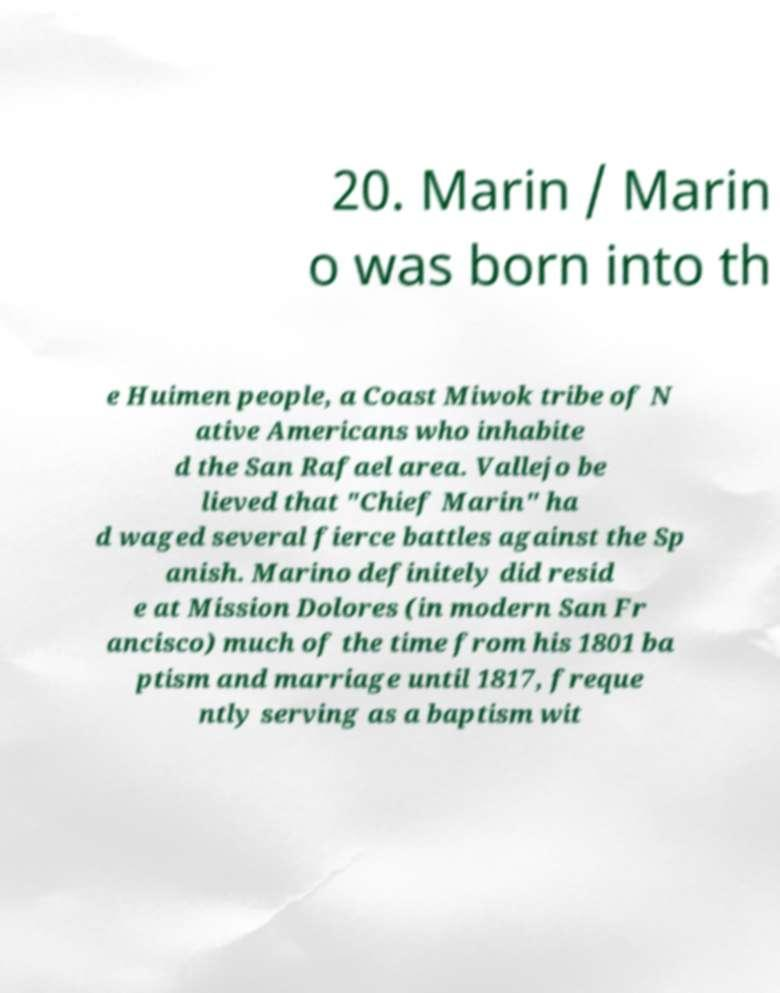I need the written content from this picture converted into text. Can you do that? 20. Marin / Marin o was born into th e Huimen people, a Coast Miwok tribe of N ative Americans who inhabite d the San Rafael area. Vallejo be lieved that "Chief Marin" ha d waged several fierce battles against the Sp anish. Marino definitely did resid e at Mission Dolores (in modern San Fr ancisco) much of the time from his 1801 ba ptism and marriage until 1817, freque ntly serving as a baptism wit 